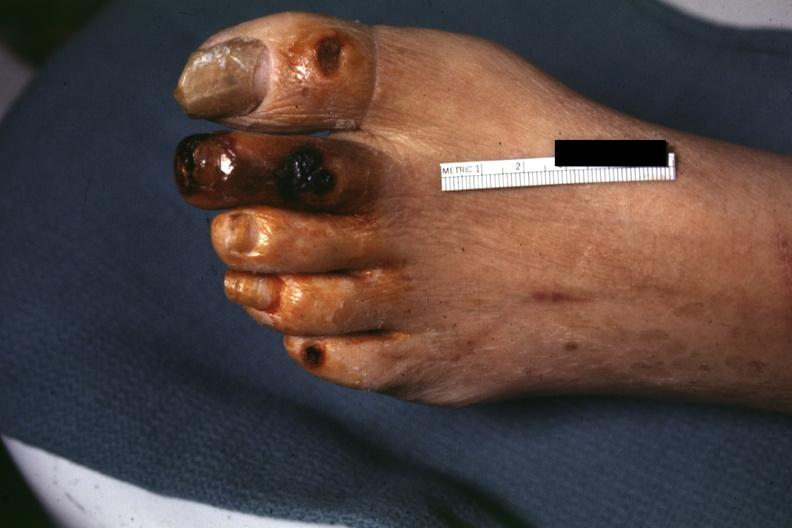does mucoepidermoid carcinoma show good close-up of gangrene?
Answer the question using a single word or phrase. No 